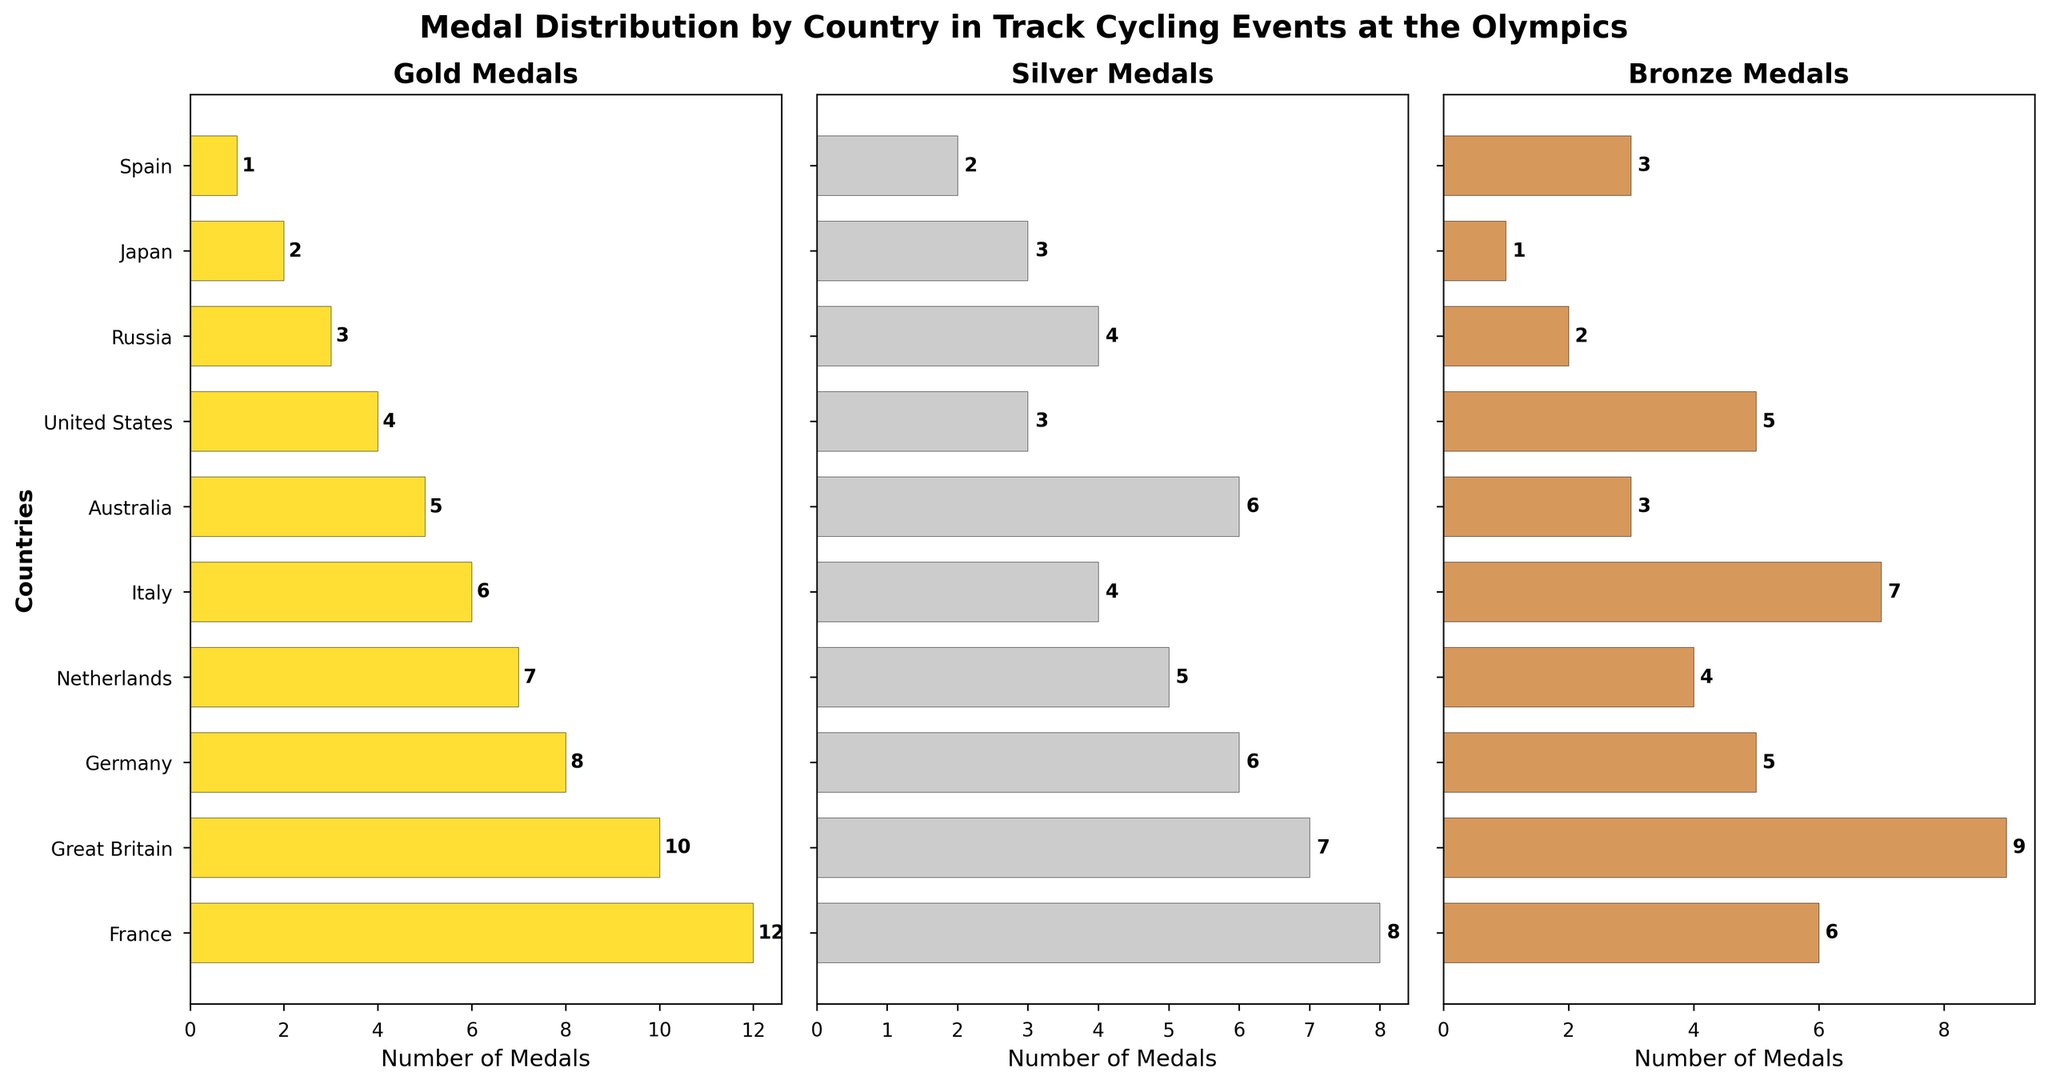Which country has the highest number of gold medals? The figure's gold medal subplot shows that France has the most gold medals, as indicated by the highest bar.
Answer: France Which country has fewer silver medals, Russia or Germany? By comparing the heights of the bars in the silver medal subplot, Germany has 6 silver medals, while Russia has 4.
Answer: Russia What is the total number of bronze medals won by Italy and Japan combined? In the bronze medal subplot, Italy has 7 medals and Japan has 1. Combining them gives 7 + 1 = 8.
Answer: 8 How many more gold medals does Australia have compared to the United States? Australia has 5 gold medals and the United States has 4, so Australia has 5 - 4 = 1 more gold medal.
Answer: 1 Which country ranks higher in terms of total silver medals, Australia or Great Britain? The subplot for silver medals shows that Australia has 6, while Great Britain has 7. Therefore, Great Britain has more silver medals.
Answer: Great Britain What is the average number of silver medals won by the top three countries? The top three countries in the silver medals subplot are France (8), Great Britain (7), and Germany (6). The average is (8 + 7 + 6) / 3 = 21 / 3 = 7.
Answer: 7 Which country has the same number of bronze medals as Japan but more gold medals than Japan? Japan has 1 bronze medal. Comparing the countries in the bronze medal subplot, no other country has exactly 1 bronze medal. Therefore, no country meets both conditions.
Answer: None What is the ratio of gold to bronze medals won by France? France has 12 gold medals and 6 bronze medals. The ratio is 12:6, which simplifies to 2:1.
Answer: 2:1 Which medal category shows Great Britain leading more countries, gold or bronze? In the gold medal subplot, France leads, so Great Britain is second. In the bronze medal subplot, Great Britain has the highest number of bronze medals among all countries. Hence, Great Britain leads more countries in the bronze category.
Answer: Bronze By how many medals does the Netherlands' total count of silver medals exceed their total count of bronze medals? The subplot for silver medals shows 5 medals, and the subplot for bronze medals shows 4 medals for the Netherlands. The difference is 5 - 4 = 1.
Answer: 1 